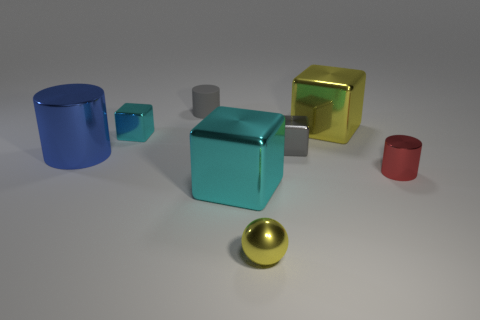Are there any other things that are the same material as the gray cylinder?
Your response must be concise. No. There is a small thing that is behind the tiny cyan block behind the tiny red shiny cylinder; how many tiny yellow metal things are behind it?
Your answer should be compact. 0. Do the tiny red shiny object and the tiny cyan metallic thing have the same shape?
Give a very brief answer. No. Is the material of the cyan thing that is in front of the tiny cyan block the same as the yellow thing behind the tiny red shiny thing?
Your answer should be very brief. Yes. What number of objects are either tiny shiny cubes on the left side of the small yellow metal object or cyan metallic cubes behind the small red cylinder?
Your answer should be compact. 1. Is there anything else that has the same shape as the rubber thing?
Offer a very short reply. Yes. How many small green metal objects are there?
Provide a succinct answer. 0. Are there any gray blocks of the same size as the sphere?
Provide a short and direct response. Yes. Does the red cylinder have the same material as the cube in front of the blue object?
Your response must be concise. Yes. There is a tiny object in front of the tiny red cylinder; what is its material?
Offer a terse response. Metal. 